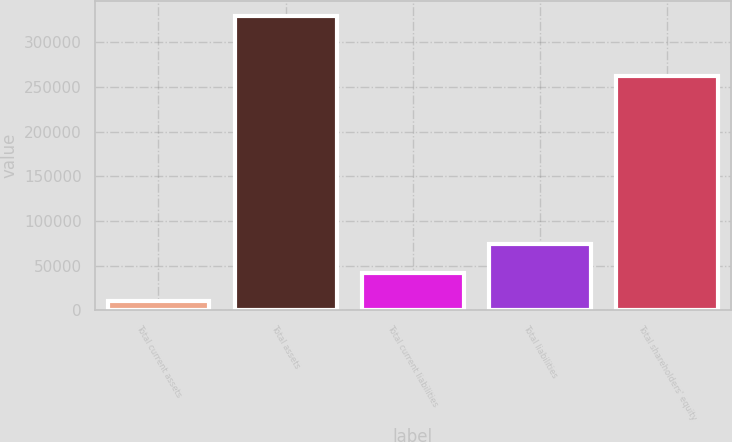<chart> <loc_0><loc_0><loc_500><loc_500><bar_chart><fcel>Total current assets<fcel>Total assets<fcel>Total current liabilities<fcel>Total liabilities<fcel>Total shareholders' equity<nl><fcel>10332<fcel>329653<fcel>42264.1<fcel>74196.2<fcel>262566<nl></chart> 